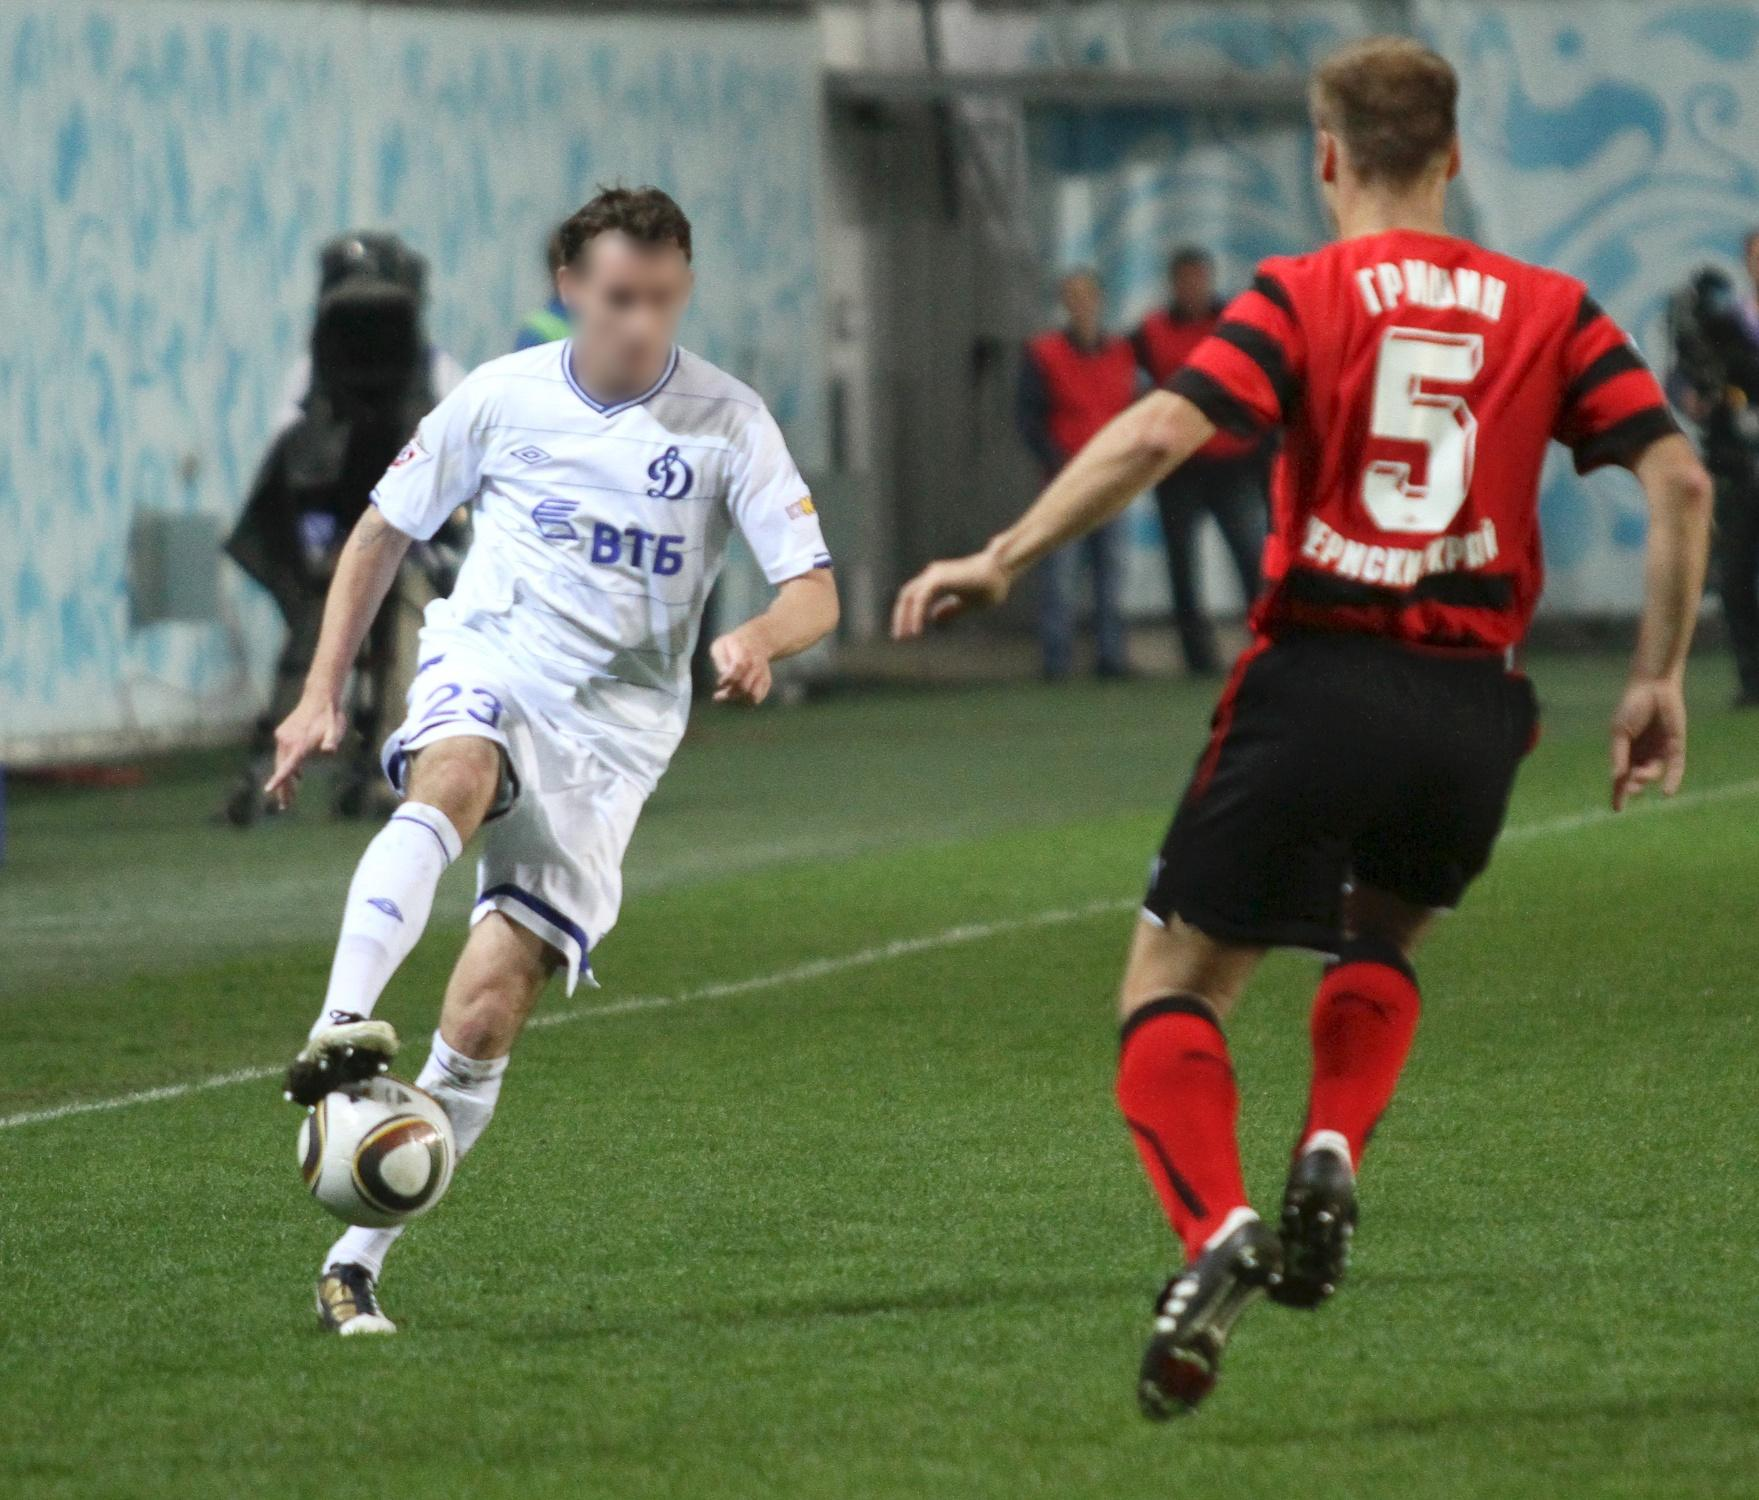What is this photo about? The image captures a dynamic moment in a thrilling soccer match. In the foreground, two players are in the midst of intense action: one in a crisp white jersey, bearing the number 23, and another in a striking red and black striped jersey marked with the number 5. They are racing towards the ball, with the player in white slightly ahead and poised to control the ball. The backdrop showcases a grand stadium adorned in blue and white, teeming with enthusiastic spectators blurred in the distance, engrossed in the unfolding drama. The lush green field contrasts vividly with the stadium's blue decor, highlighting the athletes' vibrant colors and adding to the overall intensity and excitement of the scene. 'sa_13189' appears to be an identifier or a code related to the image, yet its exact significance remains unclear without further context. 